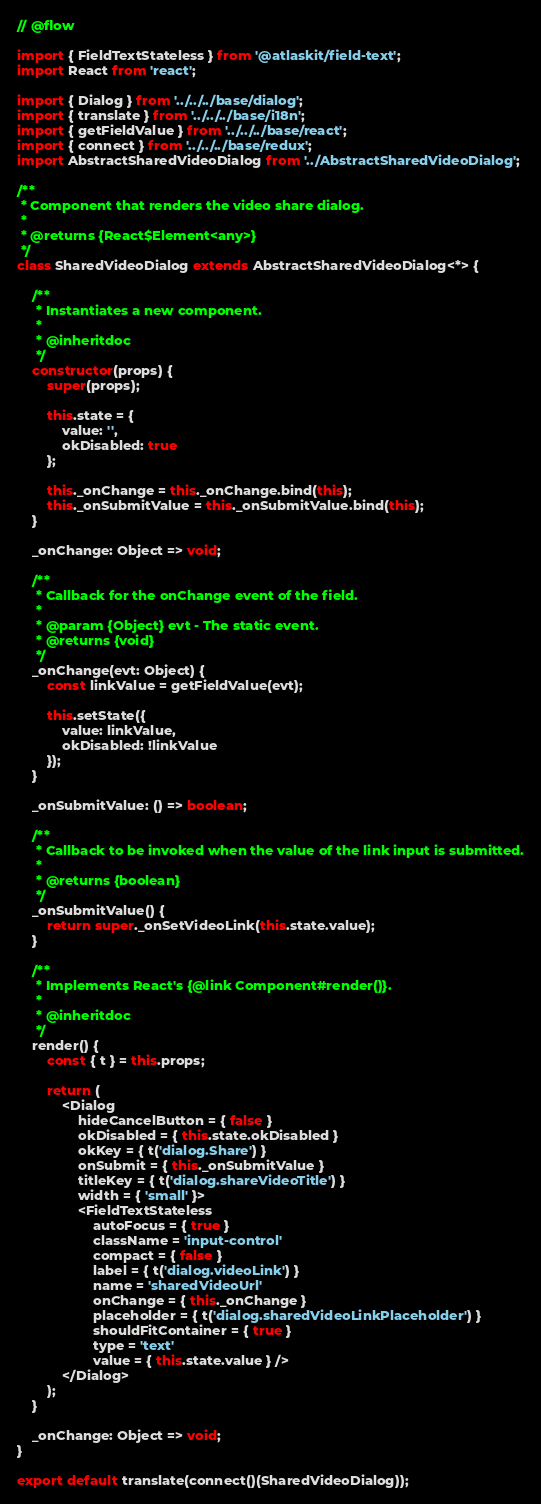<code> <loc_0><loc_0><loc_500><loc_500><_JavaScript_>// @flow

import { FieldTextStateless } from '@atlaskit/field-text';
import React from 'react';

import { Dialog } from '../../../base/dialog';
import { translate } from '../../../base/i18n';
import { getFieldValue } from '../../../base/react';
import { connect } from '../../../base/redux';
import AbstractSharedVideoDialog from '../AbstractSharedVideoDialog';

/**
 * Component that renders the video share dialog.
 *
 * @returns {React$Element<any>}
 */
class SharedVideoDialog extends AbstractSharedVideoDialog<*> {

    /**
     * Instantiates a new component.
     *
     * @inheritdoc
     */
    constructor(props) {
        super(props);

        this.state = {
            value: '',
            okDisabled: true
        };

        this._onChange = this._onChange.bind(this);
        this._onSubmitValue = this._onSubmitValue.bind(this);
    }

    _onChange: Object => void;

    /**
     * Callback for the onChange event of the field.
     *
     * @param {Object} evt - The static event.
     * @returns {void}
     */
    _onChange(evt: Object) {
        const linkValue = getFieldValue(evt);

        this.setState({
            value: linkValue,
            okDisabled: !linkValue
        });
    }

    _onSubmitValue: () => boolean;

    /**
     * Callback to be invoked when the value of the link input is submitted.
     *
     * @returns {boolean}
     */
    _onSubmitValue() {
        return super._onSetVideoLink(this.state.value);
    }

    /**
     * Implements React's {@link Component#render()}.
     *
     * @inheritdoc
     */
    render() {
        const { t } = this.props;

        return (
            <Dialog
                hideCancelButton = { false }
                okDisabled = { this.state.okDisabled }
                okKey = { t('dialog.Share') }
                onSubmit = { this._onSubmitValue }
                titleKey = { t('dialog.shareVideoTitle') }
                width = { 'small' }>
                <FieldTextStateless
                    autoFocus = { true }
                    className = 'input-control'
                    compact = { false }
                    label = { t('dialog.videoLink') }
                    name = 'sharedVideoUrl'
                    onChange = { this._onChange }
                    placeholder = { t('dialog.sharedVideoLinkPlaceholder') }
                    shouldFitContainer = { true }
                    type = 'text'
                    value = { this.state.value } />
            </Dialog>
        );
    }

    _onChange: Object => void;
}

export default translate(connect()(SharedVideoDialog));
</code> 